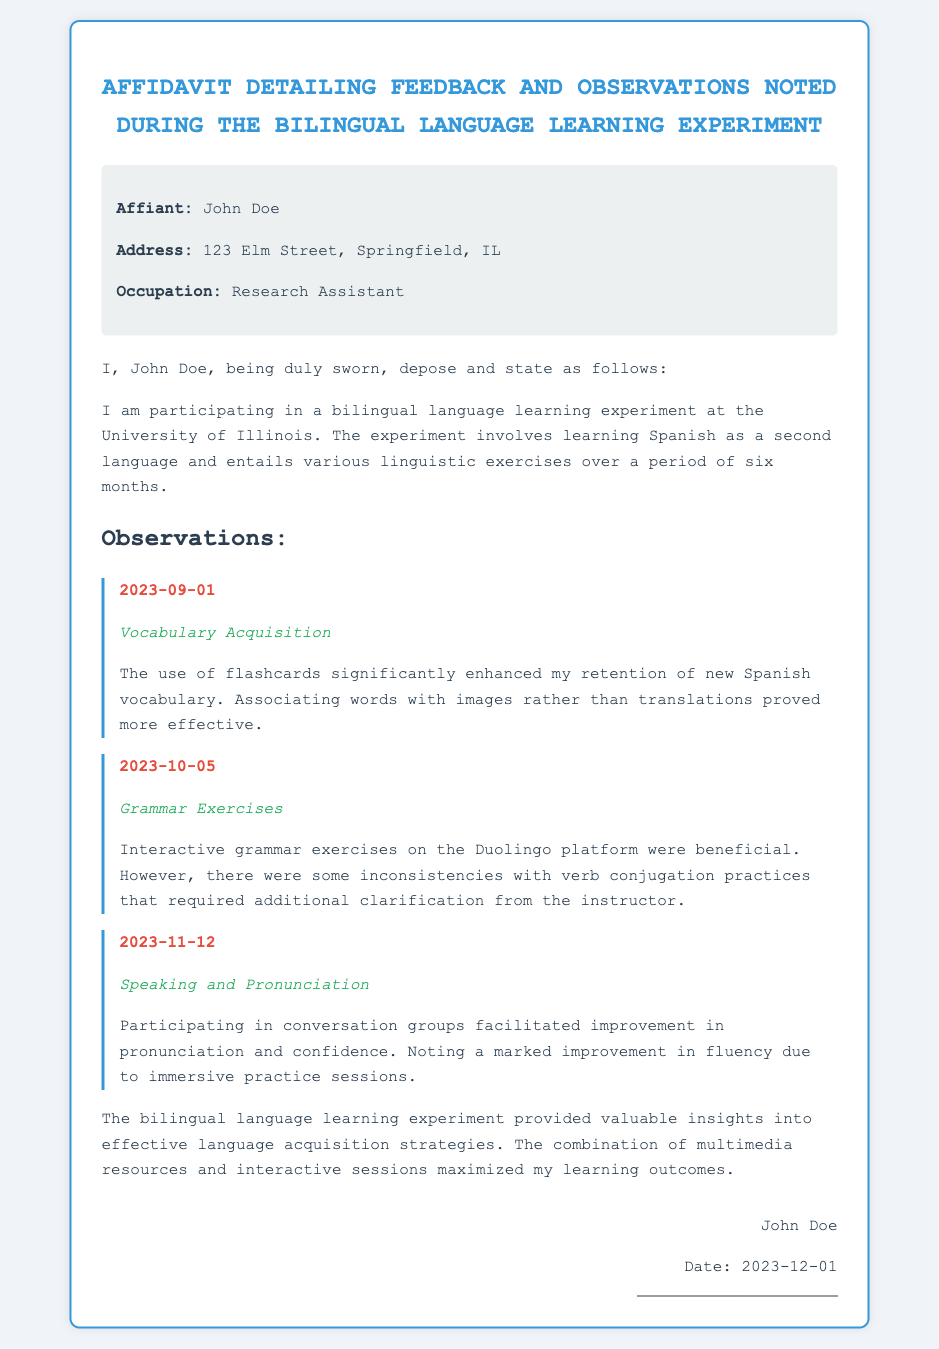What is the name of the affiant? The affiant is John Doe, as stated in the document.
Answer: John Doe What is the address of the affiant? The address provided in the affidavit is 123 Elm Street, Springfield, IL.
Answer: 123 Elm Street, Springfield, IL What is the occupation of the affiant? The document specifies that the affiant is a Research Assistant.
Answer: Research Assistant What date did the vocabulary acquisition observation occur? The observation date for vocabulary acquisition is mentioned as 2023-09-01.
Answer: 2023-09-01 What platform did the affiant use for grammar exercises? The document states that interactive grammar exercises were on the Duolingo platform.
Answer: Duolingo What aspect of language learning showed marked improvement? The affidavit notes improvement in fluency due to immersive practice sessions.
Answer: Fluency What type of experiment is detailed in the affidavit? The document describes a bilingual language learning experiment involving Spanish as a second language.
Answer: Bilingual language learning experiment How long is the duration of the language learning experiment? The affidavit indicates that the experiment lasts over a period of six months.
Answer: Six months What is the date of the signature on the affidavit? The signed date is noted as 2023-12-01 at the end of the document.
Answer: 2023-12-01 